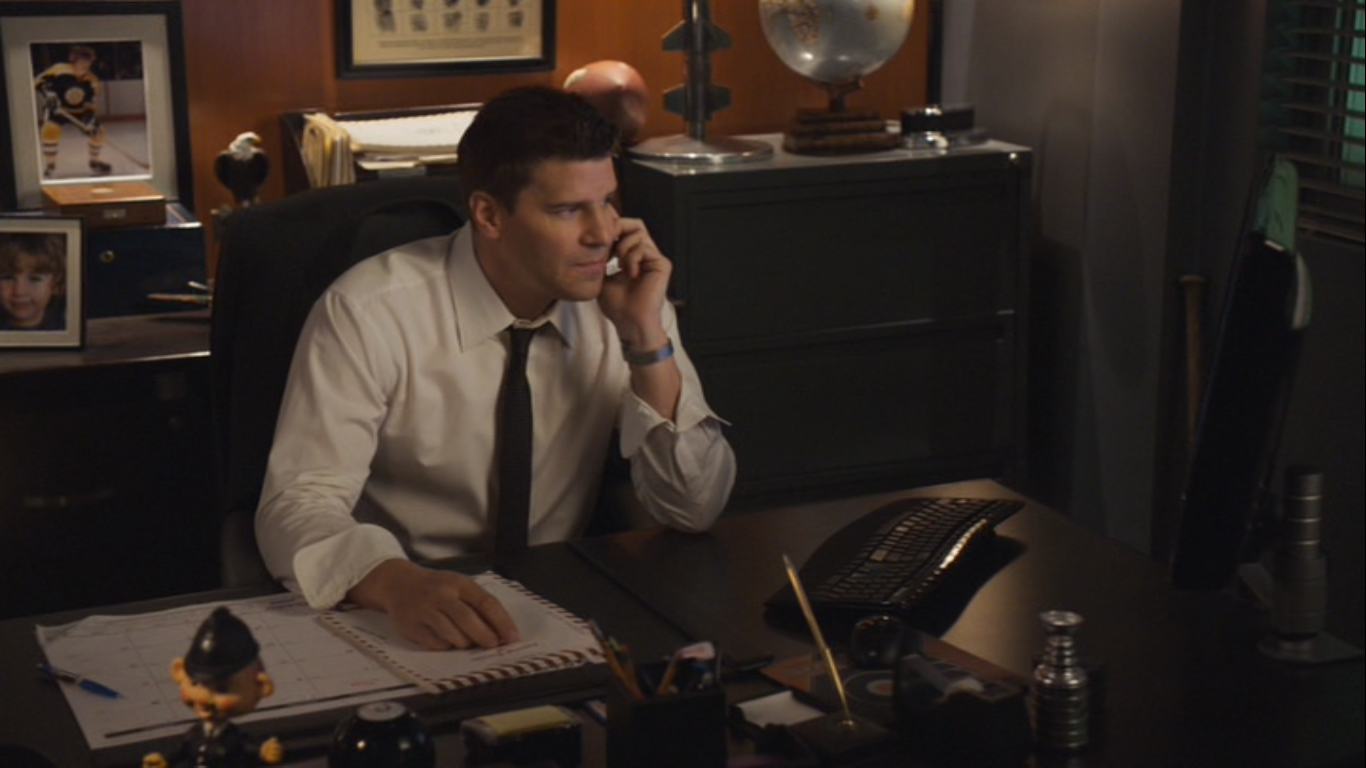What deeper themes might this image represent? This image encapsulates themes of dedication, professionalism, and the personal sacrifices made in demanding careers. The character's intense focus and the meticulous arrangement of his desk suggest a well-organized mind deeply involved in his work. The presence of the child's photo hints at the personal cost and motivation behind his professional drive—perhaps a reminder of who he's fighting to protect every day. The globe on his desk may symbolize the far-reaching impact of his work and the global nature of the challenges he faces. The combination of personal and professional elements in the image portrays the intricate balance between duty and personal life, underscoring the emotional and moral complexities in such roles. 